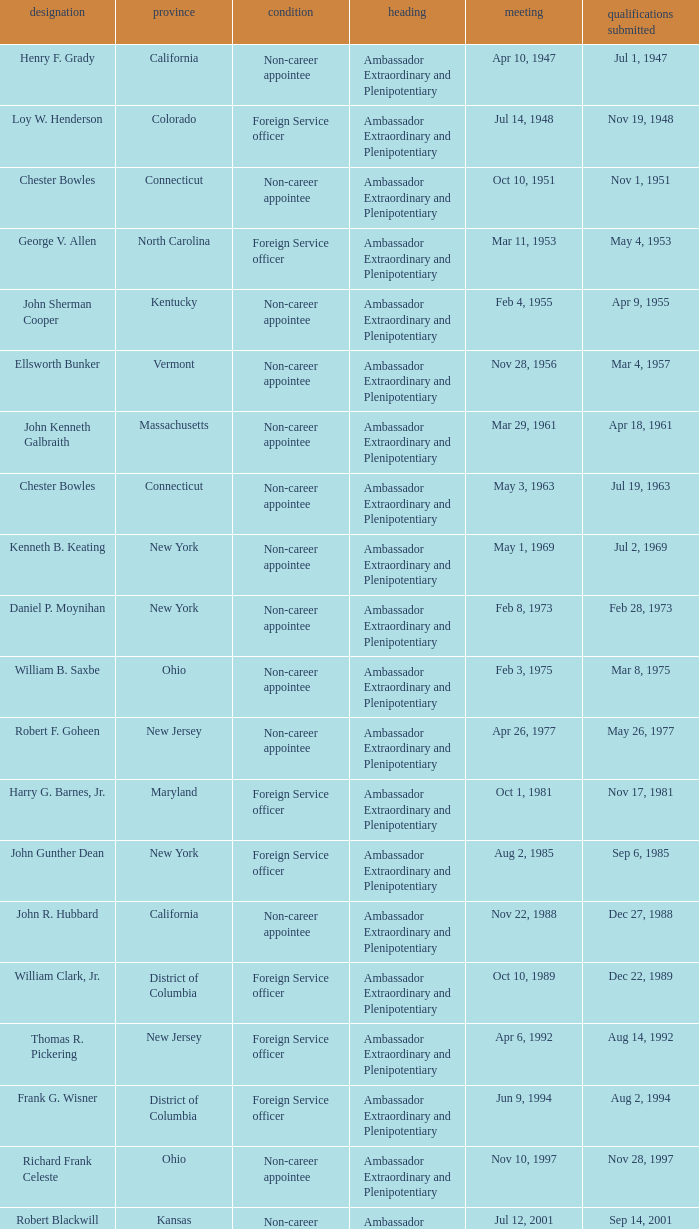What day was the appointment when Credentials Presented was jul 2, 1969? May 1, 1969. 